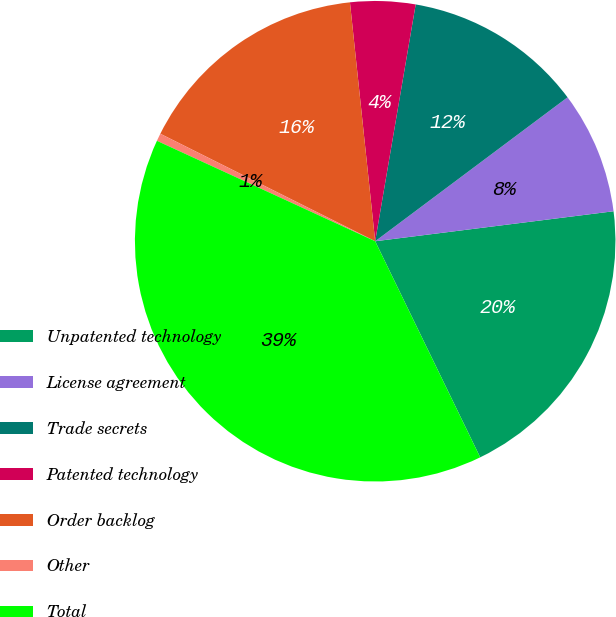<chart> <loc_0><loc_0><loc_500><loc_500><pie_chart><fcel>Unpatented technology<fcel>License agreement<fcel>Trade secrets<fcel>Patented technology<fcel>Order backlog<fcel>Other<fcel>Total<nl><fcel>19.79%<fcel>8.23%<fcel>12.08%<fcel>4.37%<fcel>15.94%<fcel>0.52%<fcel>39.06%<nl></chart> 